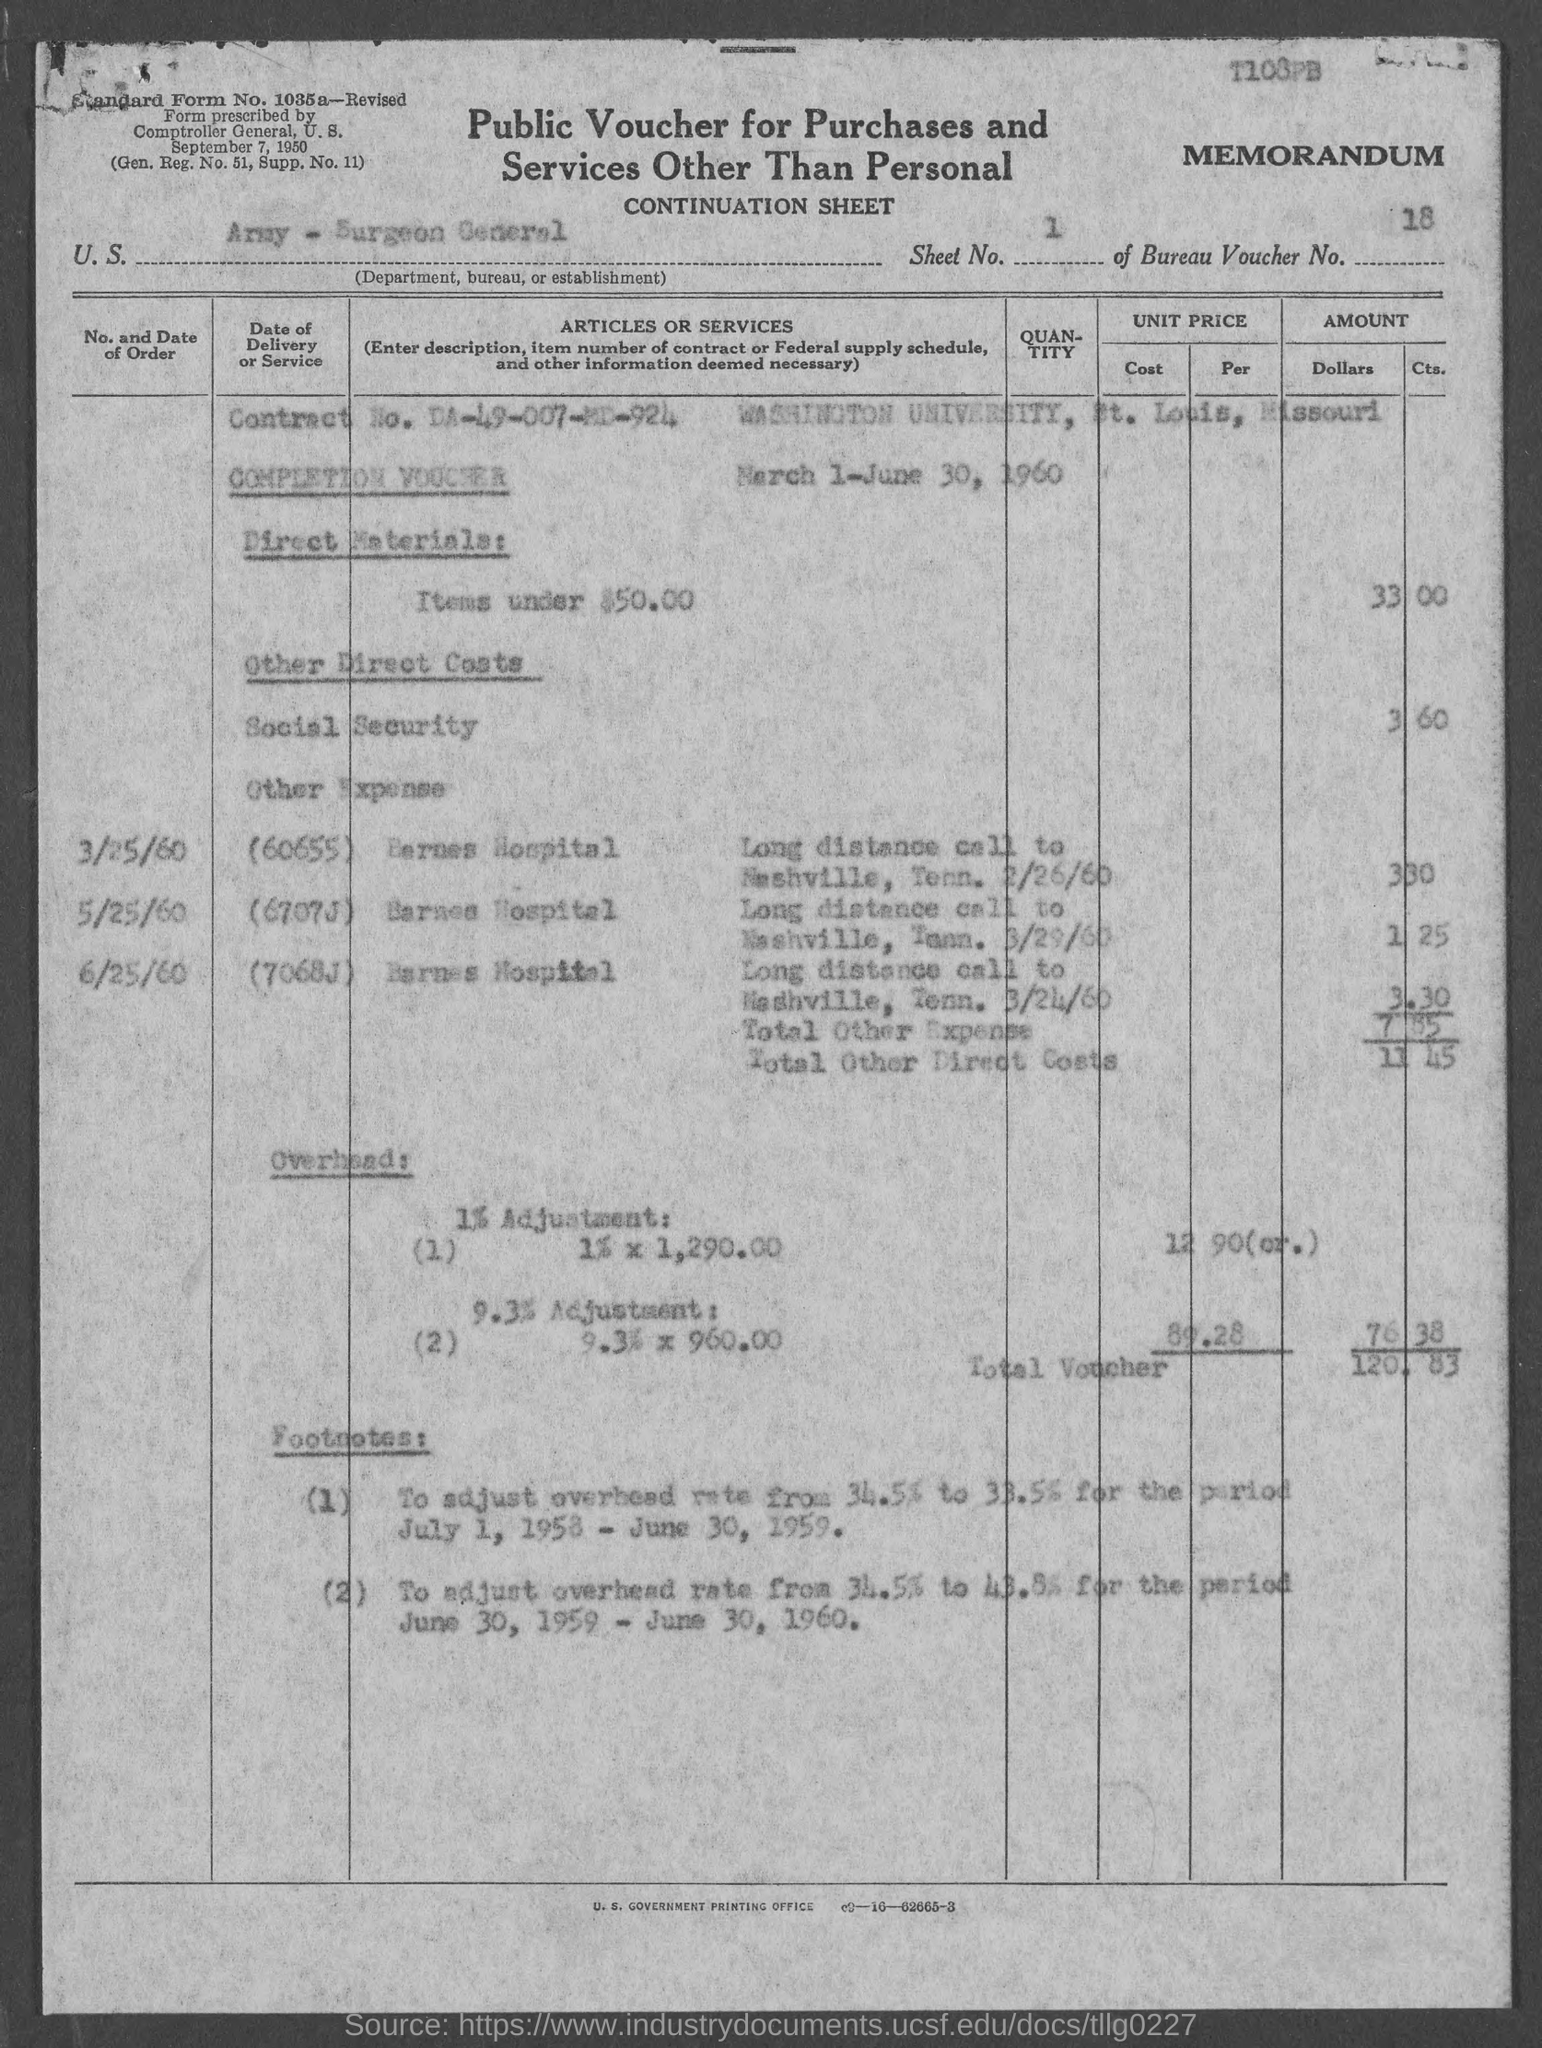What type of voucher is given here?
Your answer should be compact. Public Voucher for Purchases and Services other than Personal. What is the U.S. Department, Bureau, or Establishment given in the voucher?
Provide a succinct answer. Army - Surgeon General. What is the Sheet No. mentioned in the voucher?
Keep it short and to the point. 1. What is the Bureau Voucher No. given in the document?
Ensure brevity in your answer.  18. 